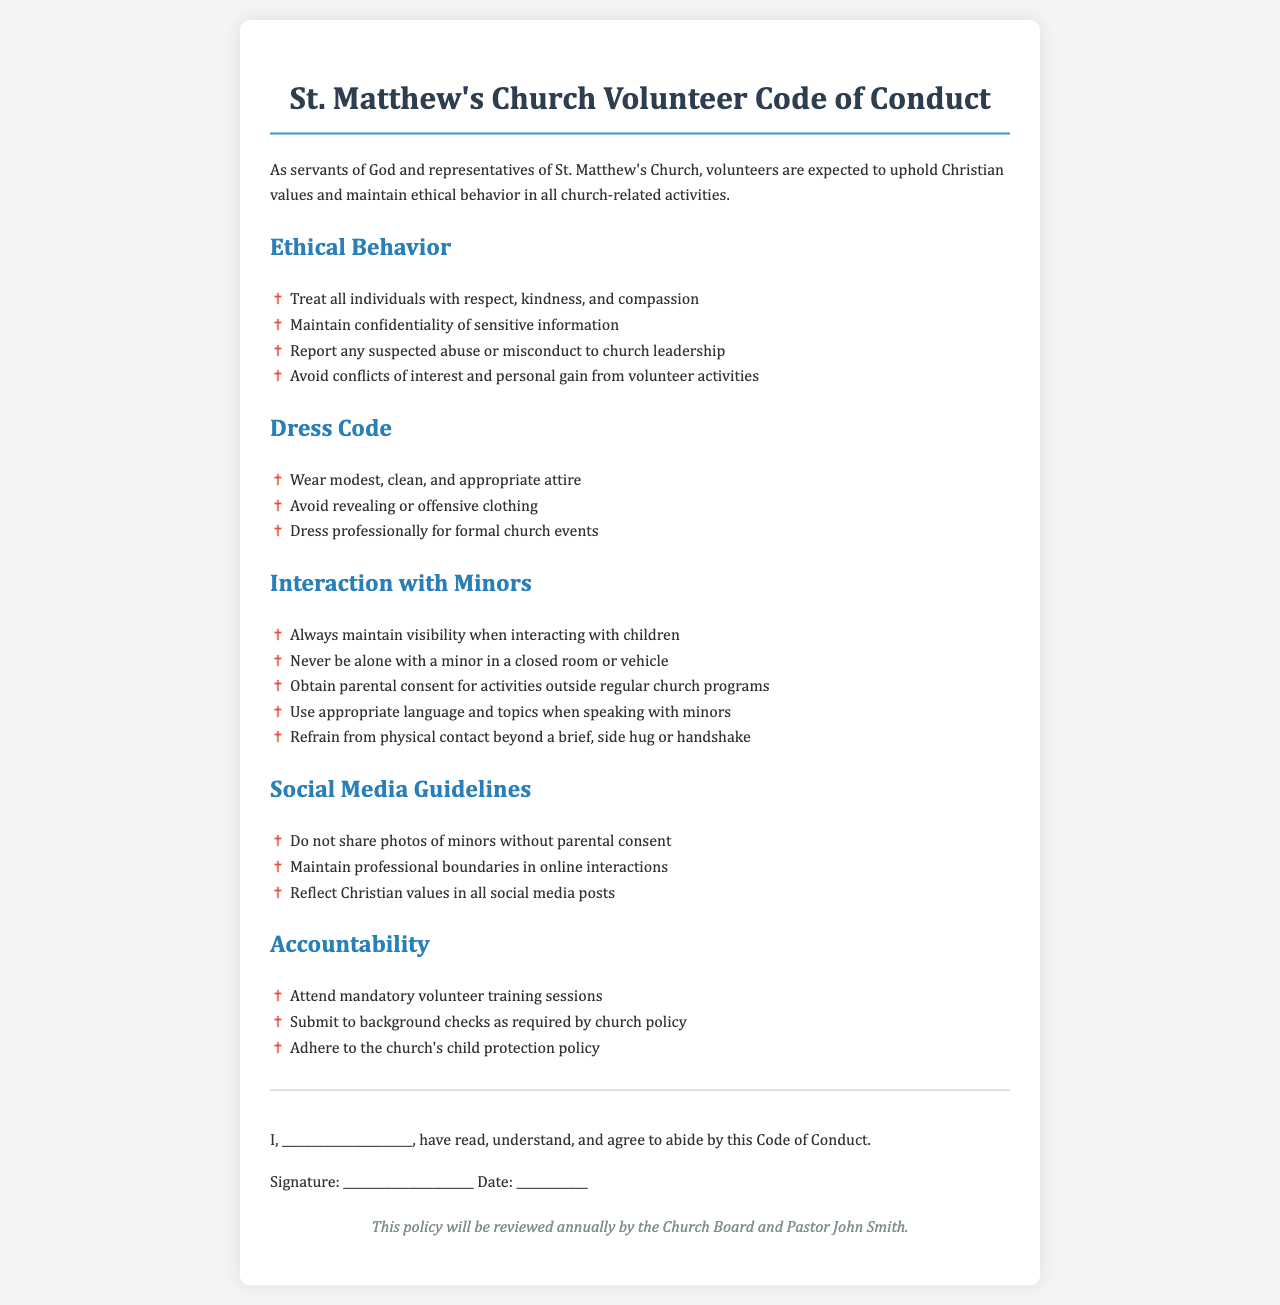What is the title of the document? The title of the document is found at the top of the rendered document.
Answer: St. Matthew's Church Volunteer Code of Conduct Who should report suspected abuse? The policy states that suspected abuse or misconduct should be reported to church leadership.
Answer: Church leadership What attire is required for formal church events? The dress code section outlines specific guidelines for formal events.
Answer: Professional attire How should volunteers interact with minors? Guidelines for interaction with minors are outlined in a specific section.
Answer: Maintain visibility What must volunteers obtain for activities outside regular church programs? The interaction section specifies a requirement for activities involving minors.
Answer: Parental consent How often will the policy be reviewed? The review frequency is mentioned in the final section of the document.
Answer: Annually What type of training is mandatory for volunteers? The accountability section specifies the requirement for training sessions.
Answer: Volunteer training sessions What action should be taken if a volunteer encounters a conflict of interest? The ethical behavior section emphasizes the need to address conflicts of interest appropriately.
Answer: Avoid conflicts What is one guideline for social media interactions? The social media guidelines provide specific recommendations for online behavior.
Answer: Maintain professional boundaries What is included in the signature section? The signature section provides space for an acknowledgment of the policy.
Answer: Signature and date 